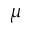Convert formula to latex. <formula><loc_0><loc_0><loc_500><loc_500>\mu</formula> 